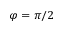<formula> <loc_0><loc_0><loc_500><loc_500>\varphi = \pi / 2</formula> 